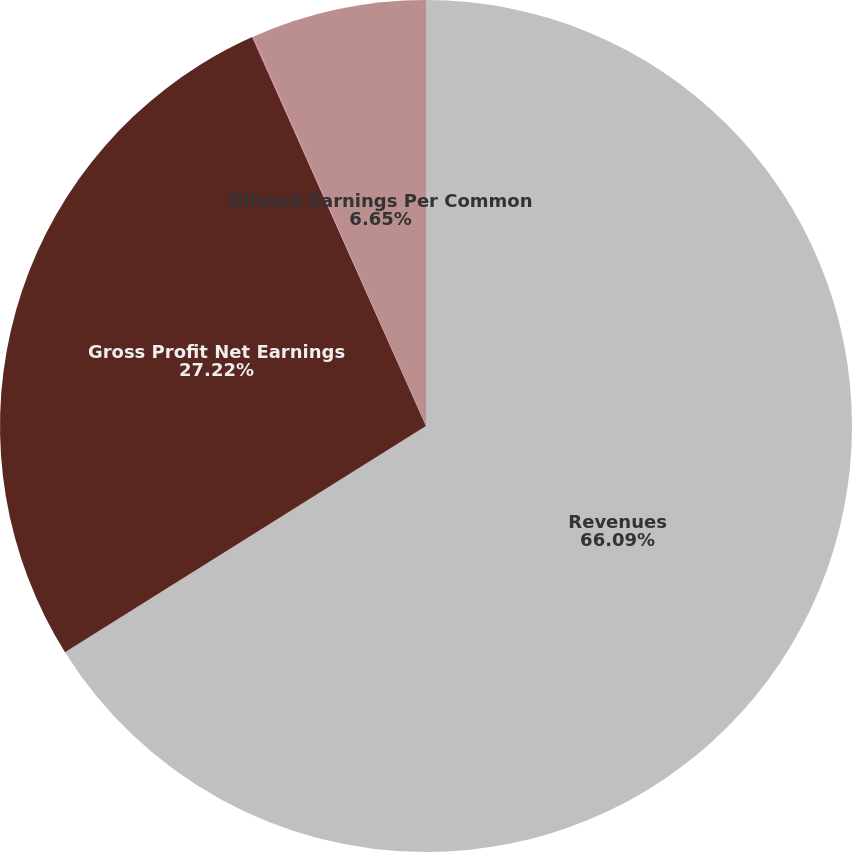<chart> <loc_0><loc_0><loc_500><loc_500><pie_chart><fcel>Revenues<fcel>Gross Profit Net Earnings<fcel>Basic Earnings Per Common<fcel>Diluted Earnings Per Common<nl><fcel>66.1%<fcel>27.22%<fcel>0.04%<fcel>6.65%<nl></chart> 